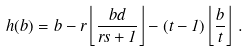<formula> <loc_0><loc_0><loc_500><loc_500>h ( b ) = b - r \left \lfloor \frac { b d } { r s + 1 } \right \rfloor - ( t - 1 ) \left \lfloor \frac { b } { t } \right \rfloor \, .</formula> 